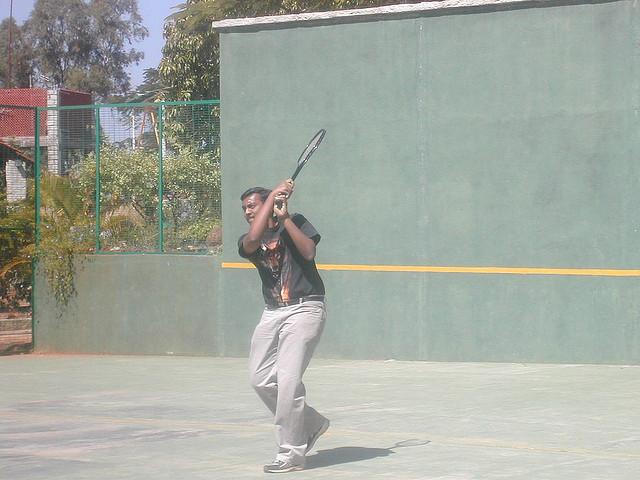What color is the wall?
Quick response, please. Green. Is the player in the picture  wearing shorts?
Give a very brief answer. No. Is it likely that this guy will fall and hurt himself?
Concise answer only. No. What is the player holding in his hands?
Write a very short answer. Tennis racket. What sport is this guy doing?
Quick response, please. Tennis. 